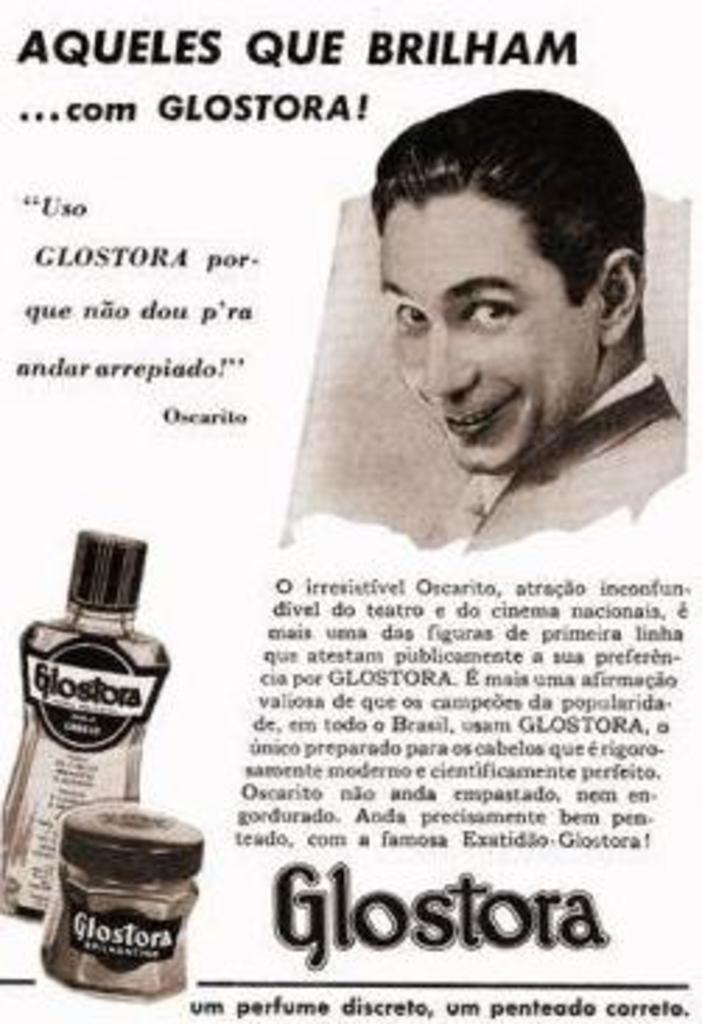Provide a one-sentence caption for the provided image. Advertisement showing a man's face and is titled "Aqueles Que Brilham". 